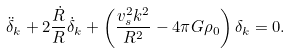Convert formula to latex. <formula><loc_0><loc_0><loc_500><loc_500>\ddot { \delta } _ { k } + 2 \frac { \dot { R } } { R } \dot { \delta } _ { k } + \left ( \frac { v ^ { 2 } _ { s } k ^ { 2 } } { R ^ { 2 } } - 4 \pi G \rho _ { 0 } \right ) \delta _ { k } = 0 .</formula> 